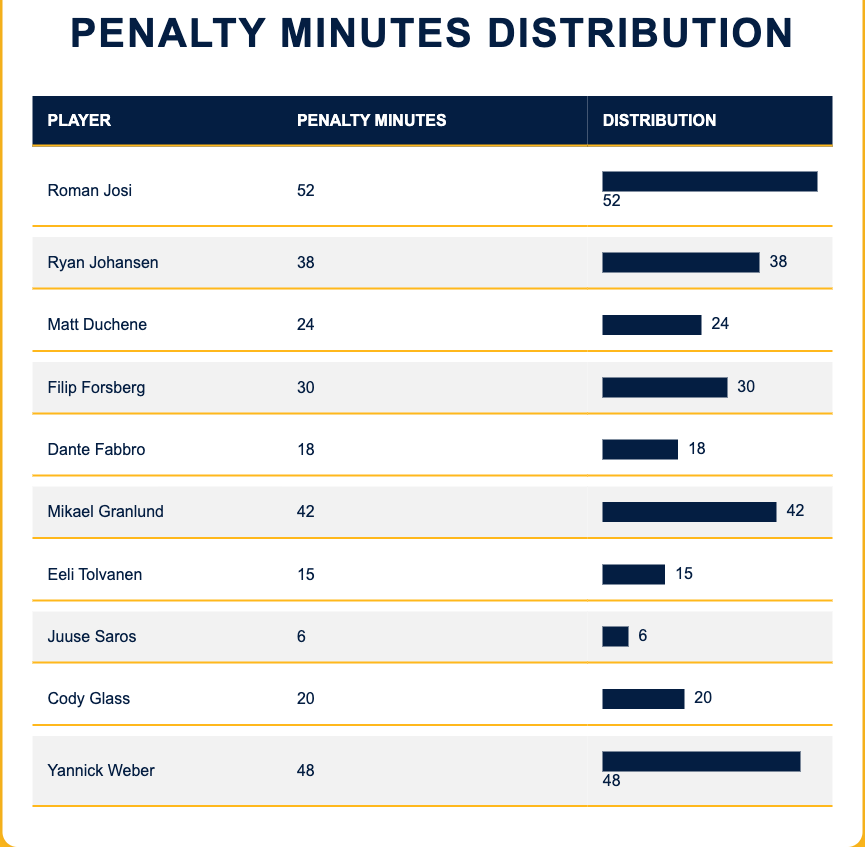What is the player with the highest penalty minutes? By reviewing the penalty minutes column, we see that Roman Josi has the highest value at 52 penalty minutes.
Answer: Roman Josi How many players have more than 30 penalty minutes? Checking the table, the players with more than 30 penalty minutes are Roman Josi (52), Ryan Johansen (38), Mikael Granlund (42), and Yannick Weber (48). There are four players in total.
Answer: 4 What is the total penalty minutes recorded by all players? To find the total, we need to sum the penalty minutes: 52 + 38 + 24 + 30 + 18 + 42 + 15 + 6 + 20 + 48 = 303.
Answer: 303 Is Mikael Granlund one of the top three players with the highest penalty minutes? The top three players in terms of penalty minutes are Roman Josi (52), Mikael Granlund (42), and Yannick Weber (48). Hence, Mikael Granlund is indeed among them.
Answer: Yes What is the average penalty minutes across all players? First, we calculated the total penalty minutes, which is 303, and there are 10 players. So, the average is 303 divided by 10, which equals 30.3.
Answer: 30.3 Who has the least penalty minutes among the players? Looking at the penalty minutes column, the player with the least penalty minutes is Juuse Saros, who has 6 penalty minutes.
Answer: Juuse Saros How many players have penalty minutes less than 20? From the table, Dante Fabbro (18), Eeli Tolvanen (15), and Juuse Saros (6) have less than 20 penalty minutes, totaling three players.
Answer: 3 If you combine the penalty minutes of Matt Duchene and Cody Glass, how many are there? Summing Matt Duchene's penalty minutes (24) and Cody Glass's penalty minutes (20) gives us 24 + 20 = 44.
Answer: 44 Which player has penalty minutes closest to the average? The average penalty minutes calculated is 30.3. The players closest to this value are Filip Forsberg with 30 minutes and Cody Glass with 20 minutes. Filip Forsberg is closer as it is only 0.3 away, compared to Cody's 10.3.
Answer: Filip Forsberg 